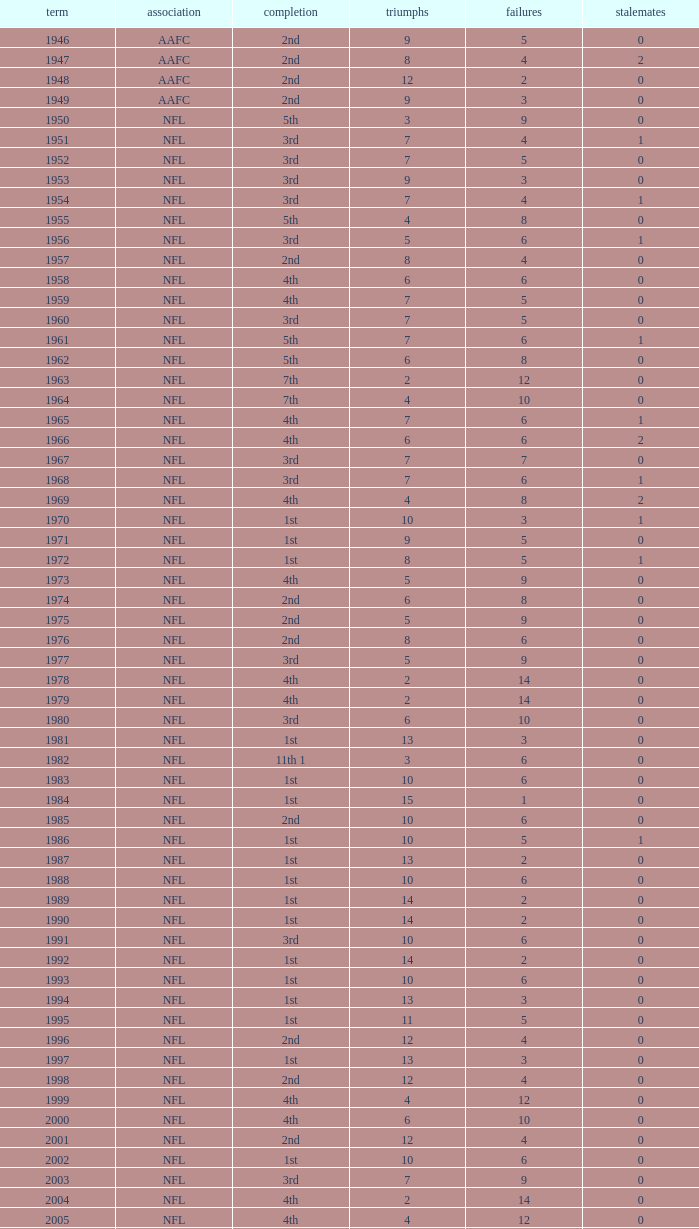What is the lowest number of ties in the NFL, with less than 2 losses and less than 15 wins? None. 